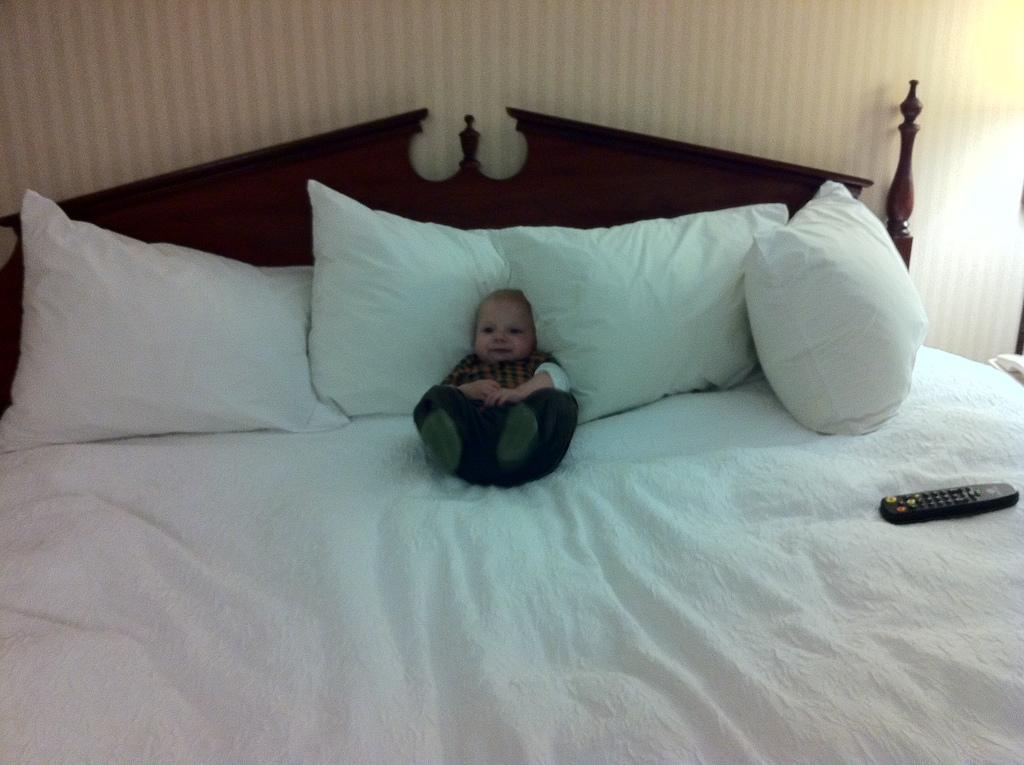Describe this image in one or two sentences. In this picture we can see a kid laying on the bed. These are the pillows and this is remote. On the background there is a wall. 